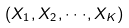<formula> <loc_0><loc_0><loc_500><loc_500>( X _ { 1 } , X _ { 2 } , \cdot \cdot \cdot , X _ { K } )</formula> 